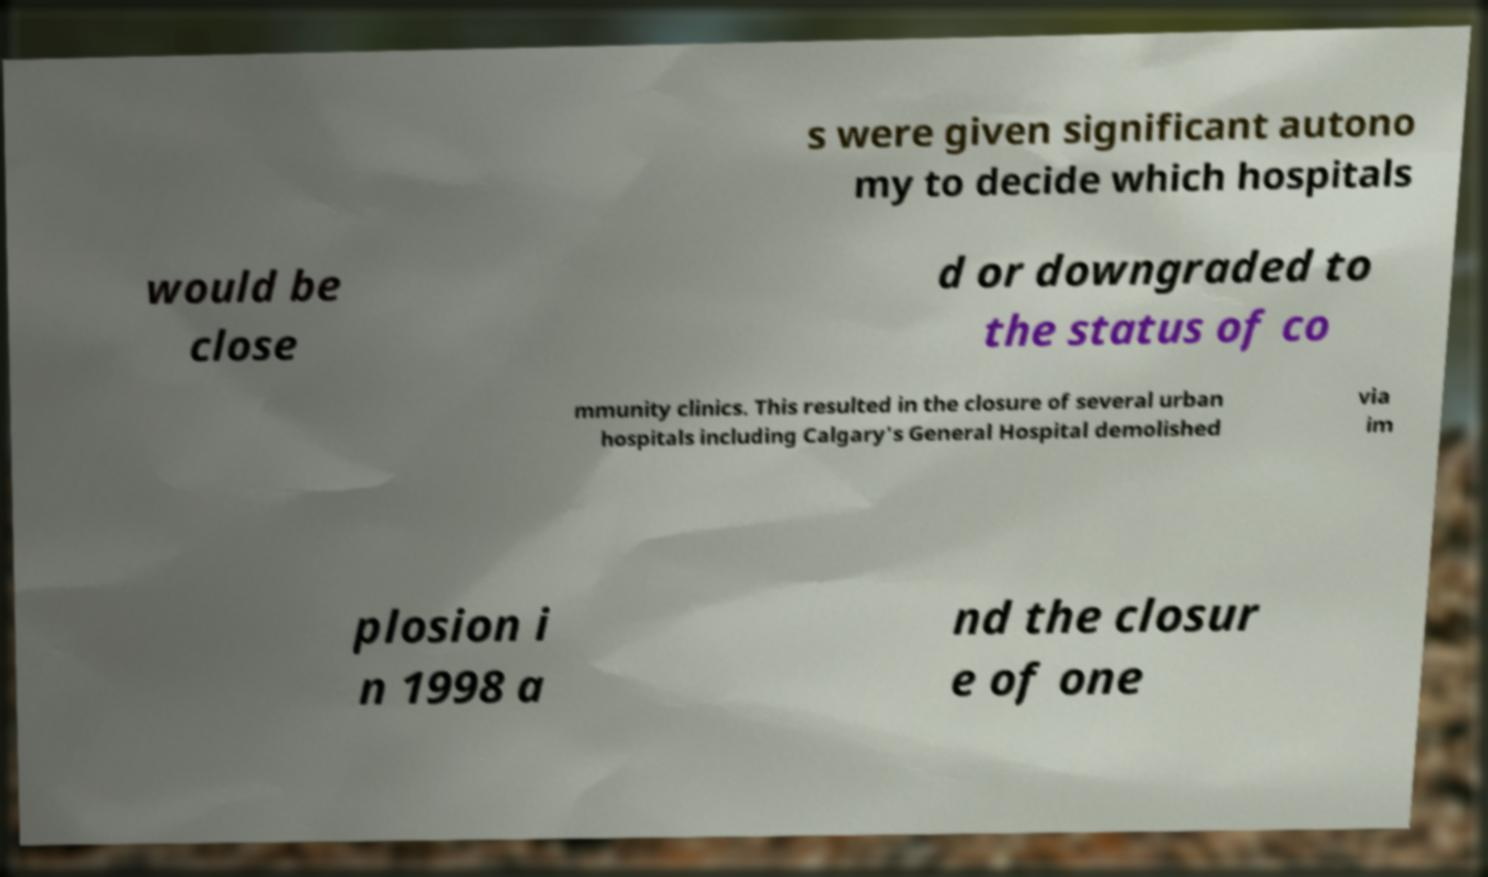Could you assist in decoding the text presented in this image and type it out clearly? s were given significant autono my to decide which hospitals would be close d or downgraded to the status of co mmunity clinics. This resulted in the closure of several urban hospitals including Calgary's General Hospital demolished via im plosion i n 1998 a nd the closur e of one 